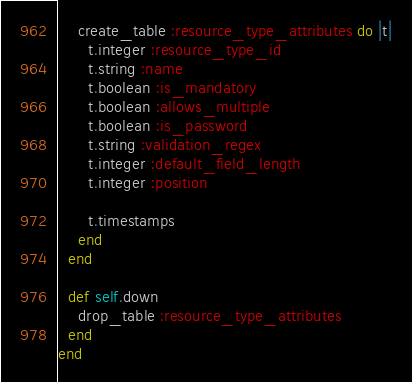<code> <loc_0><loc_0><loc_500><loc_500><_Ruby_>    create_table :resource_type_attributes do |t|
      t.integer :resource_type_id
      t.string :name
      t.boolean :is_mandatory
      t.boolean :allows_multiple
      t.boolean :is_password
      t.string :validation_regex
      t.integer :default_field_length
      t.integer :position

      t.timestamps
    end
  end

  def self.down
    drop_table :resource_type_attributes
  end
end
</code> 